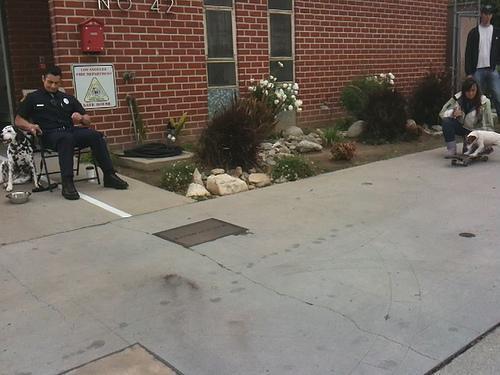How many dogs are there?
Give a very brief answer. 2. How many people are with dogs?
Give a very brief answer. 2. How many people could find a place to sit in this location?
Give a very brief answer. 1. How many people are in the picture?
Give a very brief answer. 3. 